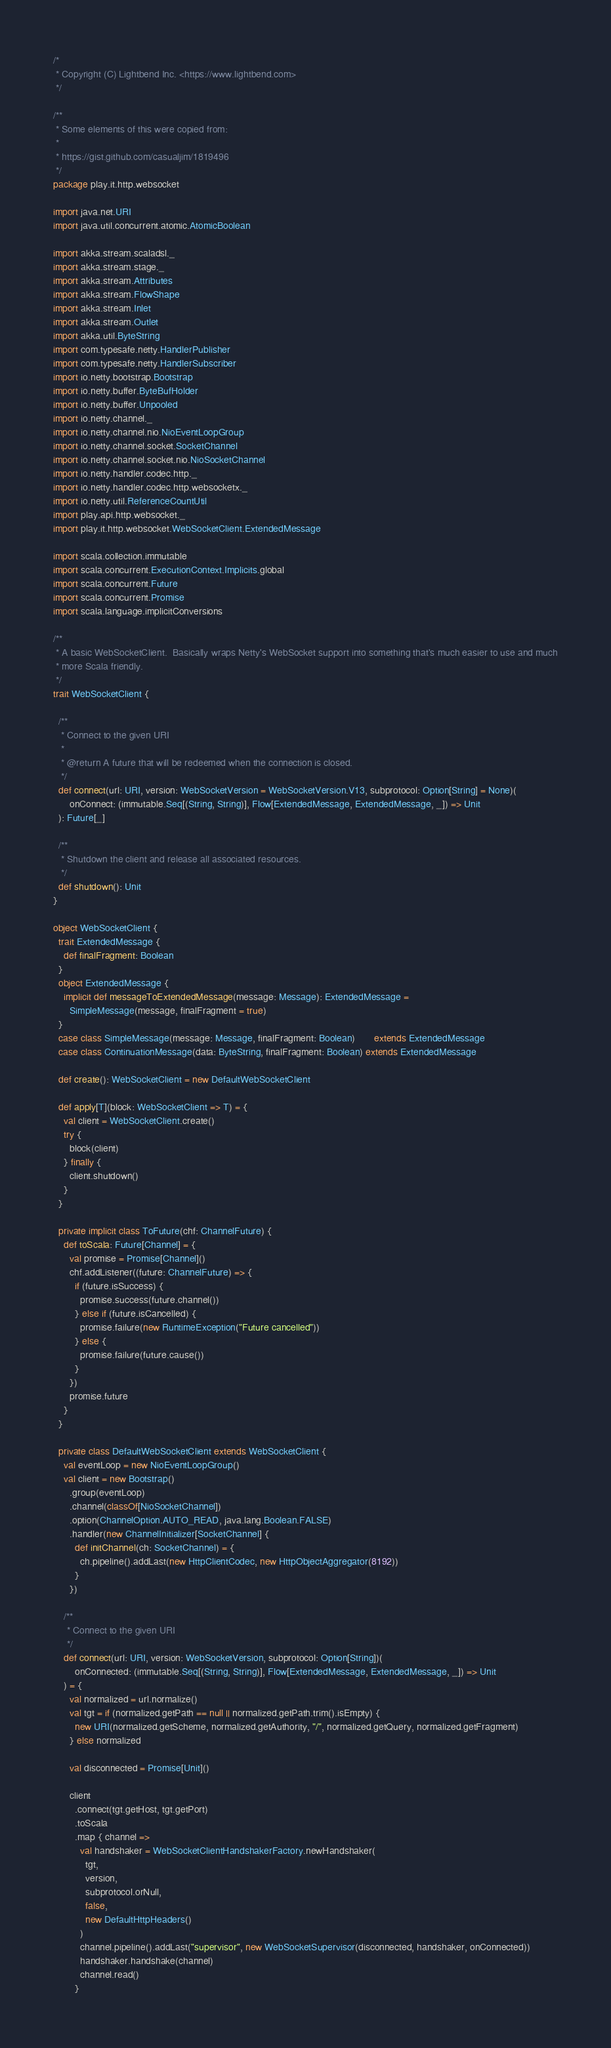<code> <loc_0><loc_0><loc_500><loc_500><_Scala_>/*
 * Copyright (C) Lightbend Inc. <https://www.lightbend.com>
 */

/**
 * Some elements of this were copied from:
 *
 * https://gist.github.com/casualjim/1819496
 */
package play.it.http.websocket

import java.net.URI
import java.util.concurrent.atomic.AtomicBoolean

import akka.stream.scaladsl._
import akka.stream.stage._
import akka.stream.Attributes
import akka.stream.FlowShape
import akka.stream.Inlet
import akka.stream.Outlet
import akka.util.ByteString
import com.typesafe.netty.HandlerPublisher
import com.typesafe.netty.HandlerSubscriber
import io.netty.bootstrap.Bootstrap
import io.netty.buffer.ByteBufHolder
import io.netty.buffer.Unpooled
import io.netty.channel._
import io.netty.channel.nio.NioEventLoopGroup
import io.netty.channel.socket.SocketChannel
import io.netty.channel.socket.nio.NioSocketChannel
import io.netty.handler.codec.http._
import io.netty.handler.codec.http.websocketx._
import io.netty.util.ReferenceCountUtil
import play.api.http.websocket._
import play.it.http.websocket.WebSocketClient.ExtendedMessage

import scala.collection.immutable
import scala.concurrent.ExecutionContext.Implicits.global
import scala.concurrent.Future
import scala.concurrent.Promise
import scala.language.implicitConversions

/**
 * A basic WebSocketClient.  Basically wraps Netty's WebSocket support into something that's much easier to use and much
 * more Scala friendly.
 */
trait WebSocketClient {

  /**
   * Connect to the given URI
   *
   * @return A future that will be redeemed when the connection is closed.
   */
  def connect(url: URI, version: WebSocketVersion = WebSocketVersion.V13, subprotocol: Option[String] = None)(
      onConnect: (immutable.Seq[(String, String)], Flow[ExtendedMessage, ExtendedMessage, _]) => Unit
  ): Future[_]

  /**
   * Shutdown the client and release all associated resources.
   */
  def shutdown(): Unit
}

object WebSocketClient {
  trait ExtendedMessage {
    def finalFragment: Boolean
  }
  object ExtendedMessage {
    implicit def messageToExtendedMessage(message: Message): ExtendedMessage =
      SimpleMessage(message, finalFragment = true)
  }
  case class SimpleMessage(message: Message, finalFragment: Boolean)       extends ExtendedMessage
  case class ContinuationMessage(data: ByteString, finalFragment: Boolean) extends ExtendedMessage

  def create(): WebSocketClient = new DefaultWebSocketClient

  def apply[T](block: WebSocketClient => T) = {
    val client = WebSocketClient.create()
    try {
      block(client)
    } finally {
      client.shutdown()
    }
  }

  private implicit class ToFuture(chf: ChannelFuture) {
    def toScala: Future[Channel] = {
      val promise = Promise[Channel]()
      chf.addListener((future: ChannelFuture) => {
        if (future.isSuccess) {
          promise.success(future.channel())
        } else if (future.isCancelled) {
          promise.failure(new RuntimeException("Future cancelled"))
        } else {
          promise.failure(future.cause())
        }
      })
      promise.future
    }
  }

  private class DefaultWebSocketClient extends WebSocketClient {
    val eventLoop = new NioEventLoopGroup()
    val client = new Bootstrap()
      .group(eventLoop)
      .channel(classOf[NioSocketChannel])
      .option(ChannelOption.AUTO_READ, java.lang.Boolean.FALSE)
      .handler(new ChannelInitializer[SocketChannel] {
        def initChannel(ch: SocketChannel) = {
          ch.pipeline().addLast(new HttpClientCodec, new HttpObjectAggregator(8192))
        }
      })

    /**
     * Connect to the given URI
     */
    def connect(url: URI, version: WebSocketVersion, subprotocol: Option[String])(
        onConnected: (immutable.Seq[(String, String)], Flow[ExtendedMessage, ExtendedMessage, _]) => Unit
    ) = {
      val normalized = url.normalize()
      val tgt = if (normalized.getPath == null || normalized.getPath.trim().isEmpty) {
        new URI(normalized.getScheme, normalized.getAuthority, "/", normalized.getQuery, normalized.getFragment)
      } else normalized

      val disconnected = Promise[Unit]()

      client
        .connect(tgt.getHost, tgt.getPort)
        .toScala
        .map { channel =>
          val handshaker = WebSocketClientHandshakerFactory.newHandshaker(
            tgt,
            version,
            subprotocol.orNull,
            false,
            new DefaultHttpHeaders()
          )
          channel.pipeline().addLast("supervisor", new WebSocketSupervisor(disconnected, handshaker, onConnected))
          handshaker.handshake(channel)
          channel.read()
        }</code> 